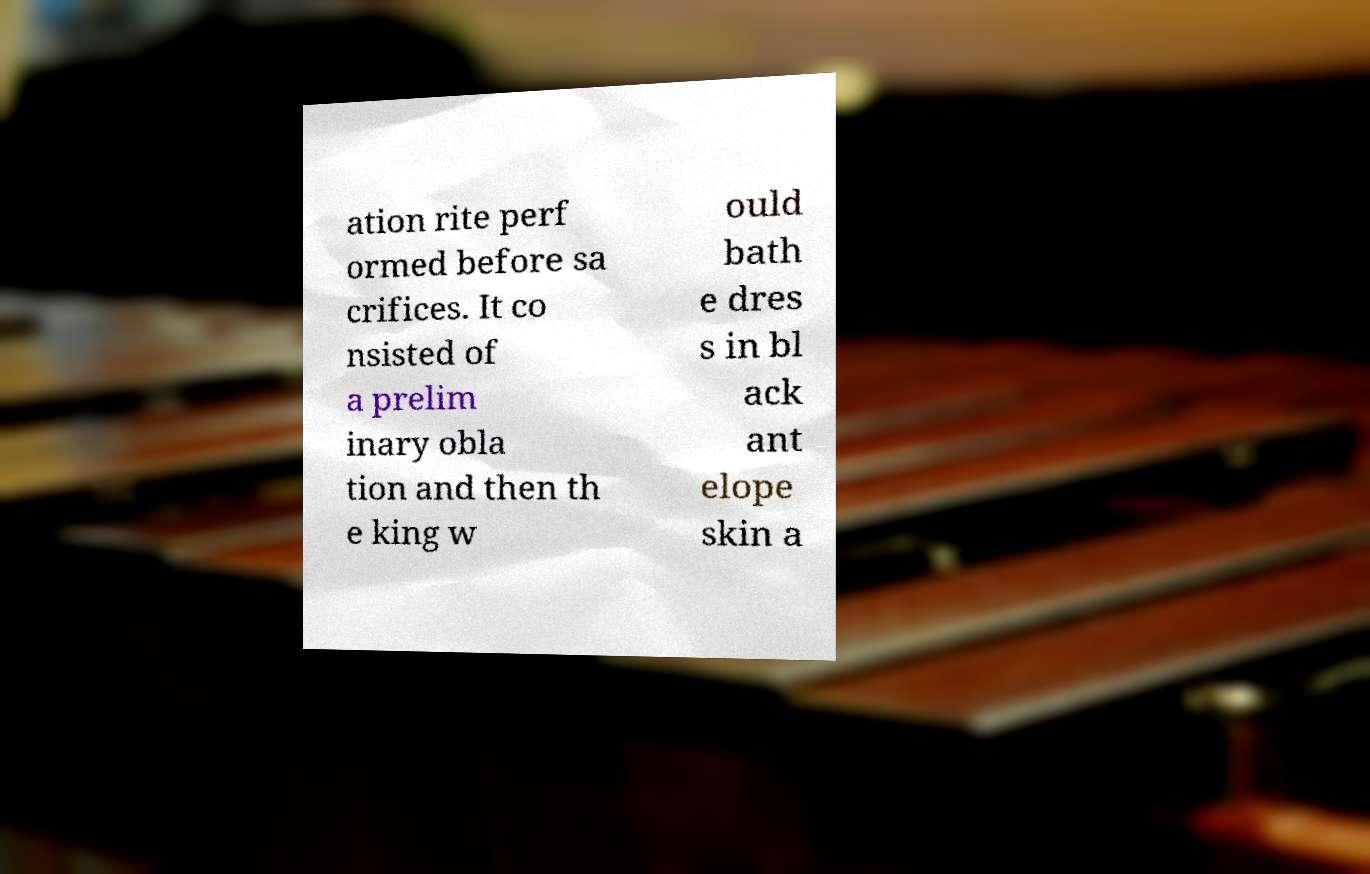Please identify and transcribe the text found in this image. ation rite perf ormed before sa crifices. It co nsisted of a prelim inary obla tion and then th e king w ould bath e dres s in bl ack ant elope skin a 